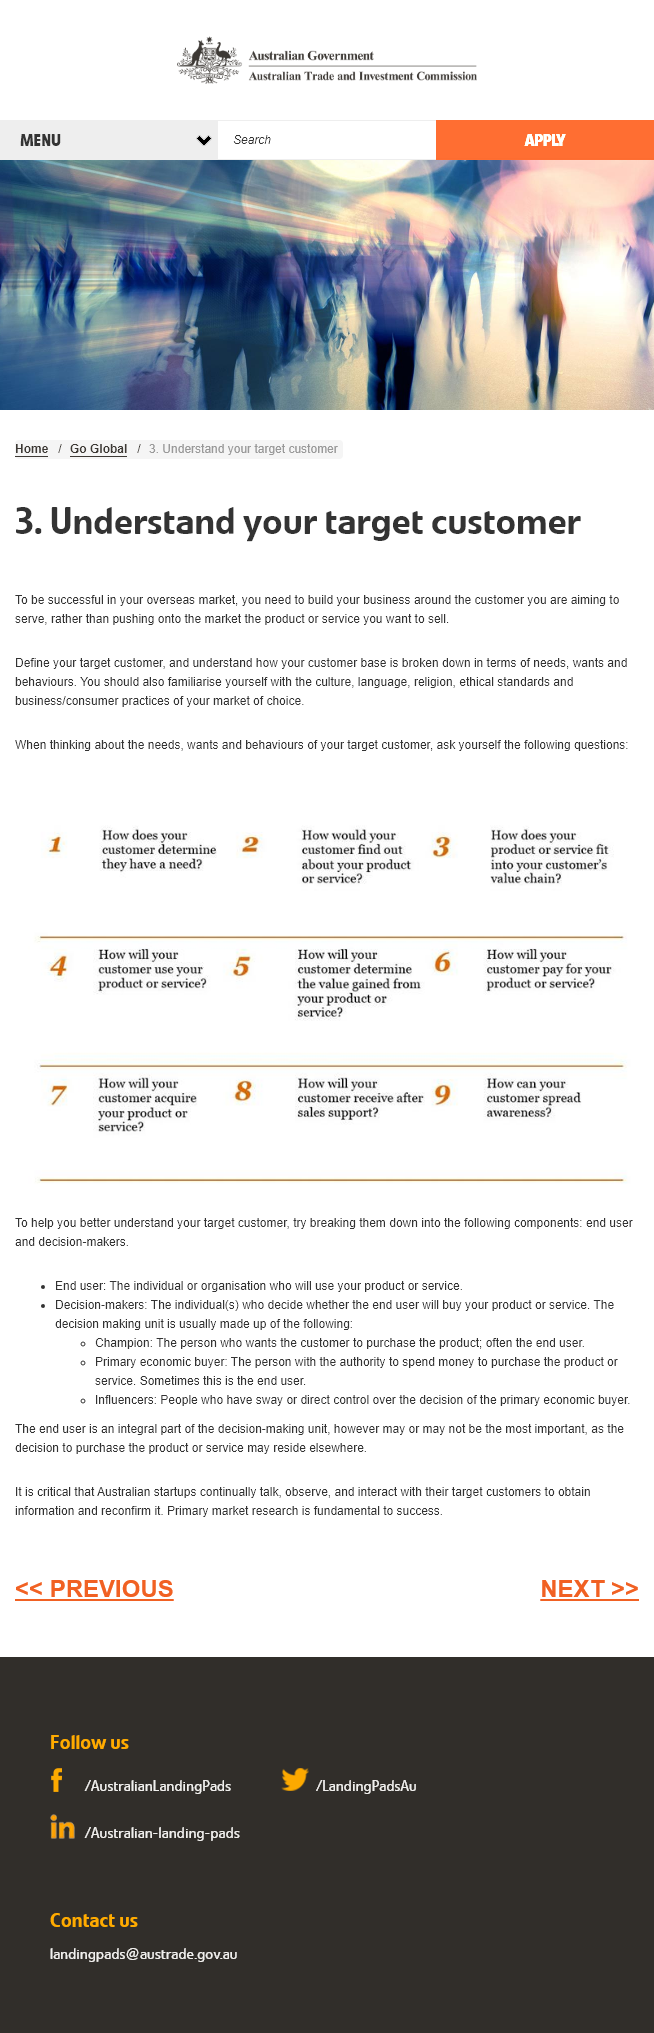Point out several critical features in this image. Yes, it is crucial to familiarize oneself with the culture of the market of choice, as understanding the target customer is key to achieving success in the market. To achieve success in the overseas market, it is essential to comprehend the segmentation of one's customer base in terms of their needs, wants, and behaviors. It is important to first define and accurately determine the target customer when attempting to understand them. 